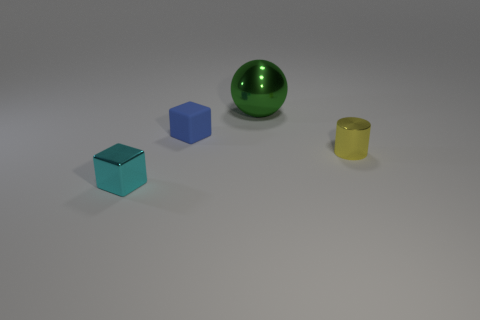Is there anything else that is made of the same material as the tiny blue cube?
Your answer should be very brief. No. What number of objects are either tiny brown rubber cylinders or tiny cubes behind the metal cube?
Give a very brief answer. 1. What color is the rubber object?
Offer a terse response. Blue. The shiny thing on the right side of the big green object is what color?
Give a very brief answer. Yellow. What number of small cubes are behind the small shiny thing behind the small cyan metallic thing?
Your answer should be compact. 1. There is a yellow cylinder; is its size the same as the metallic object behind the small blue matte cube?
Make the answer very short. No. Is there a yellow cylinder that has the same size as the blue matte block?
Offer a very short reply. Yes. What number of objects are either tiny gray matte cylinders or spheres?
Your response must be concise. 1. There is a object that is on the right side of the big sphere; is it the same size as the metallic thing to the left of the green metallic ball?
Offer a terse response. Yes. Is there a cyan metallic thing that has the same shape as the small blue thing?
Provide a short and direct response. Yes. 